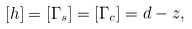Convert formula to latex. <formula><loc_0><loc_0><loc_500><loc_500>[ h ] = [ \Gamma _ { s } ] = [ \Gamma _ { c } ] = d - z ,</formula> 